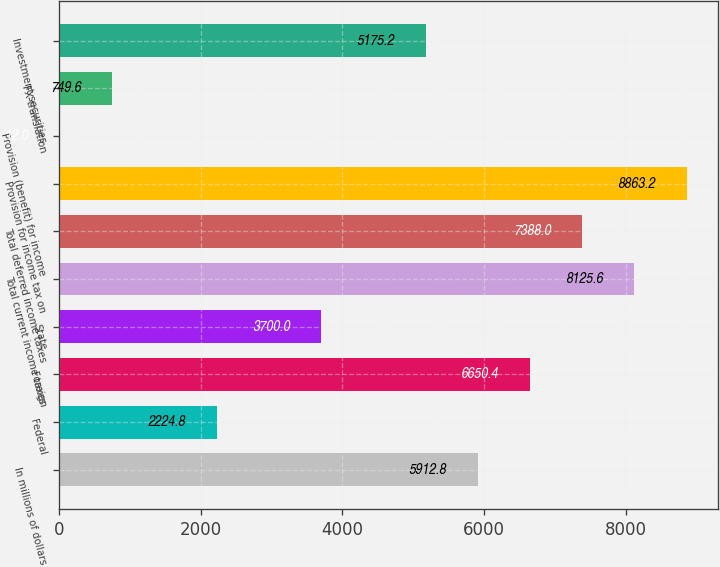<chart> <loc_0><loc_0><loc_500><loc_500><bar_chart><fcel>In millions of dollars<fcel>Federal<fcel>Foreign<fcel>State<fcel>Total current income taxes<fcel>Total deferred income taxes<fcel>Provision for income tax on<fcel>Provision (benefit) for income<fcel>FX translation<fcel>Investment securities<nl><fcel>5912.8<fcel>2224.8<fcel>6650.4<fcel>3700<fcel>8125.6<fcel>7388<fcel>8863.2<fcel>12<fcel>749.6<fcel>5175.2<nl></chart> 